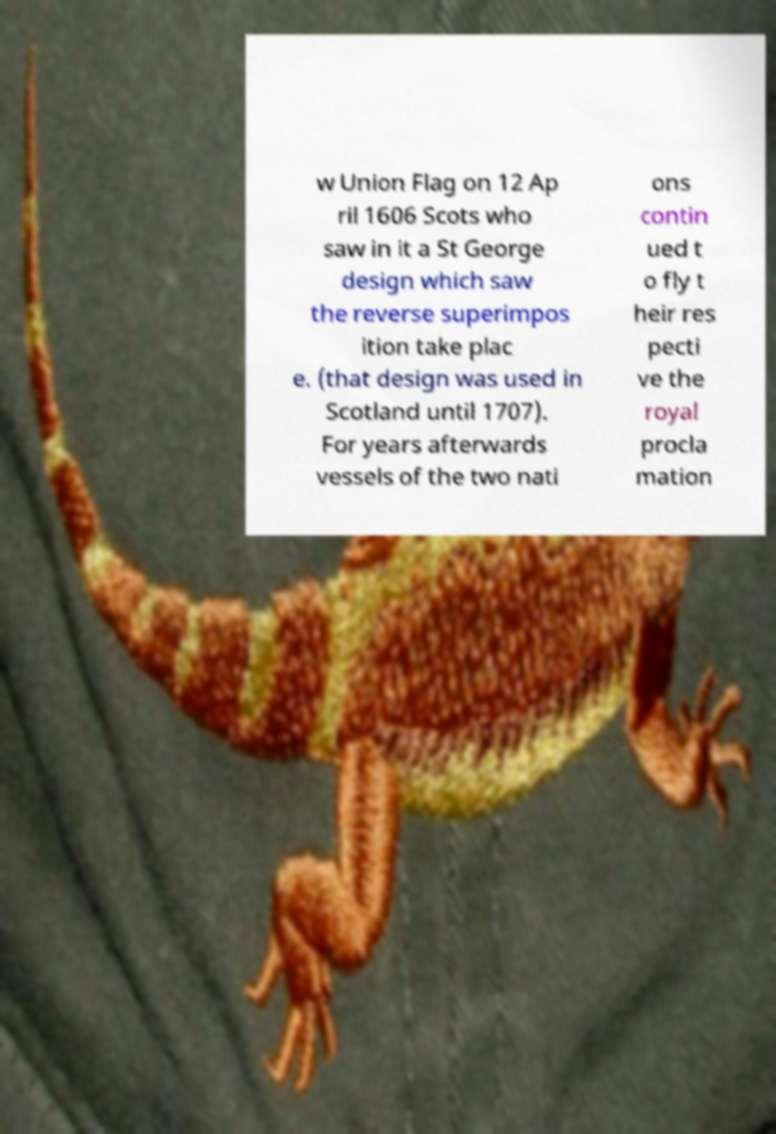There's text embedded in this image that I need extracted. Can you transcribe it verbatim? w Union Flag on 12 Ap ril 1606 Scots who saw in it a St George design which saw the reverse superimpos ition take plac e. (that design was used in Scotland until 1707). For years afterwards vessels of the two nati ons contin ued t o fly t heir res pecti ve the royal procla mation 